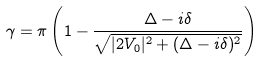<formula> <loc_0><loc_0><loc_500><loc_500>\gamma = \pi \left ( 1 - \frac { \Delta - i \delta } { \sqrt { | 2 V _ { 0 } | ^ { 2 } + ( \Delta - i \delta ) ^ { 2 } } } \right )</formula> 